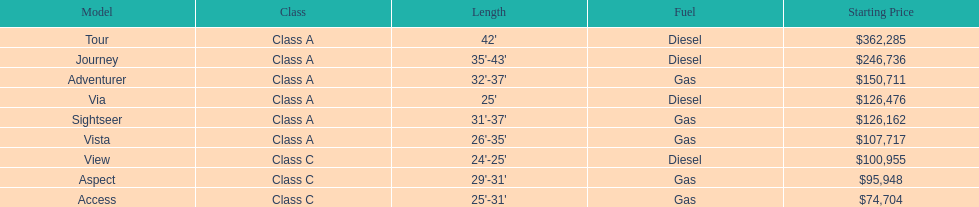Does the tour take diesel or gas? Diesel. 